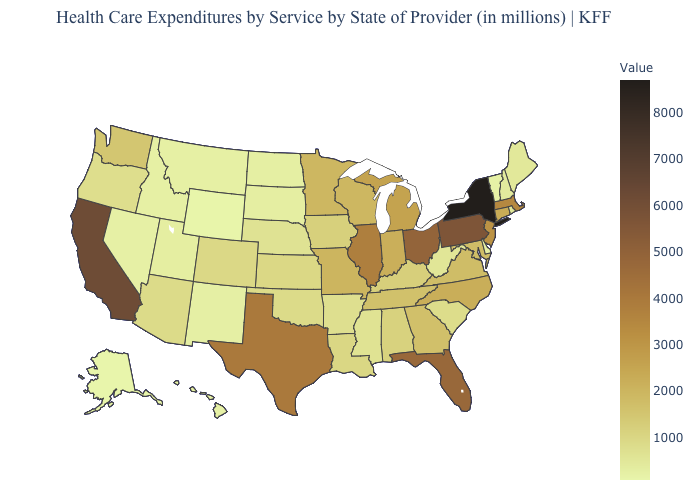Does Kansas have the highest value in the USA?
Answer briefly. No. Does Alaska have the lowest value in the USA?
Quick response, please. Yes. Among the states that border Pennsylvania , does Delaware have the lowest value?
Short answer required. Yes. Which states have the lowest value in the MidWest?
Keep it brief. North Dakota. Among the states that border Louisiana , does Mississippi have the lowest value?
Quick response, please. Yes. Which states have the lowest value in the USA?
Write a very short answer. Alaska. Which states have the highest value in the USA?
Short answer required. New York. Which states have the highest value in the USA?
Short answer required. New York. 